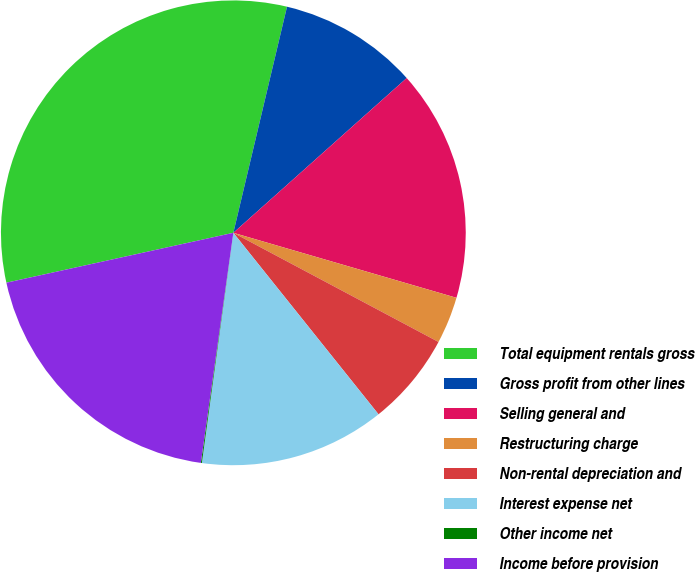Convert chart. <chart><loc_0><loc_0><loc_500><loc_500><pie_chart><fcel>Total equipment rentals gross<fcel>Gross profit from other lines<fcel>Selling general and<fcel>Restructuring charge<fcel>Non-rental depreciation and<fcel>Interest expense net<fcel>Other income net<fcel>Income before provision<nl><fcel>32.15%<fcel>9.69%<fcel>16.11%<fcel>3.27%<fcel>6.48%<fcel>12.9%<fcel>0.07%<fcel>19.32%<nl></chart> 